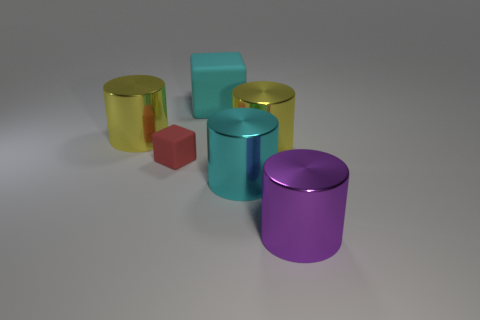What time of day or lighting conditions does the image suggest? The image appears to be taken under neutral lighting conditions, likely indoors with soft, diffused light, as there are subtle shadows beneath the objects and no harsh highlights or specific light direction indicative of natural sunlight. 